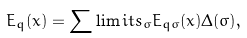Convert formula to latex. <formula><loc_0><loc_0><loc_500><loc_500>E _ { q } ( x ) = \sum \lim i t s _ { \sigma } E _ { q \sigma } ( x ) \Delta ( \sigma ) ,</formula> 